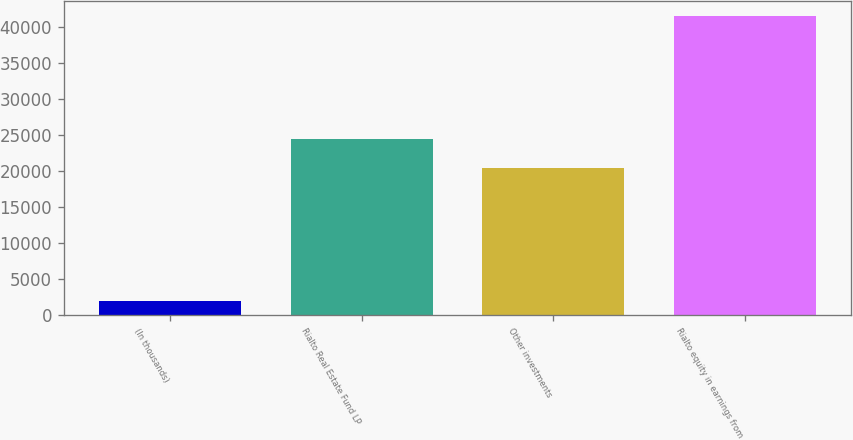Convert chart. <chart><loc_0><loc_0><loc_500><loc_500><bar_chart><fcel>(In thousands)<fcel>Rialto Real Estate Fund LP<fcel>Other investments<fcel>Rialto equity in earnings from<nl><fcel>2012<fcel>24404.1<fcel>20457<fcel>41483<nl></chart> 